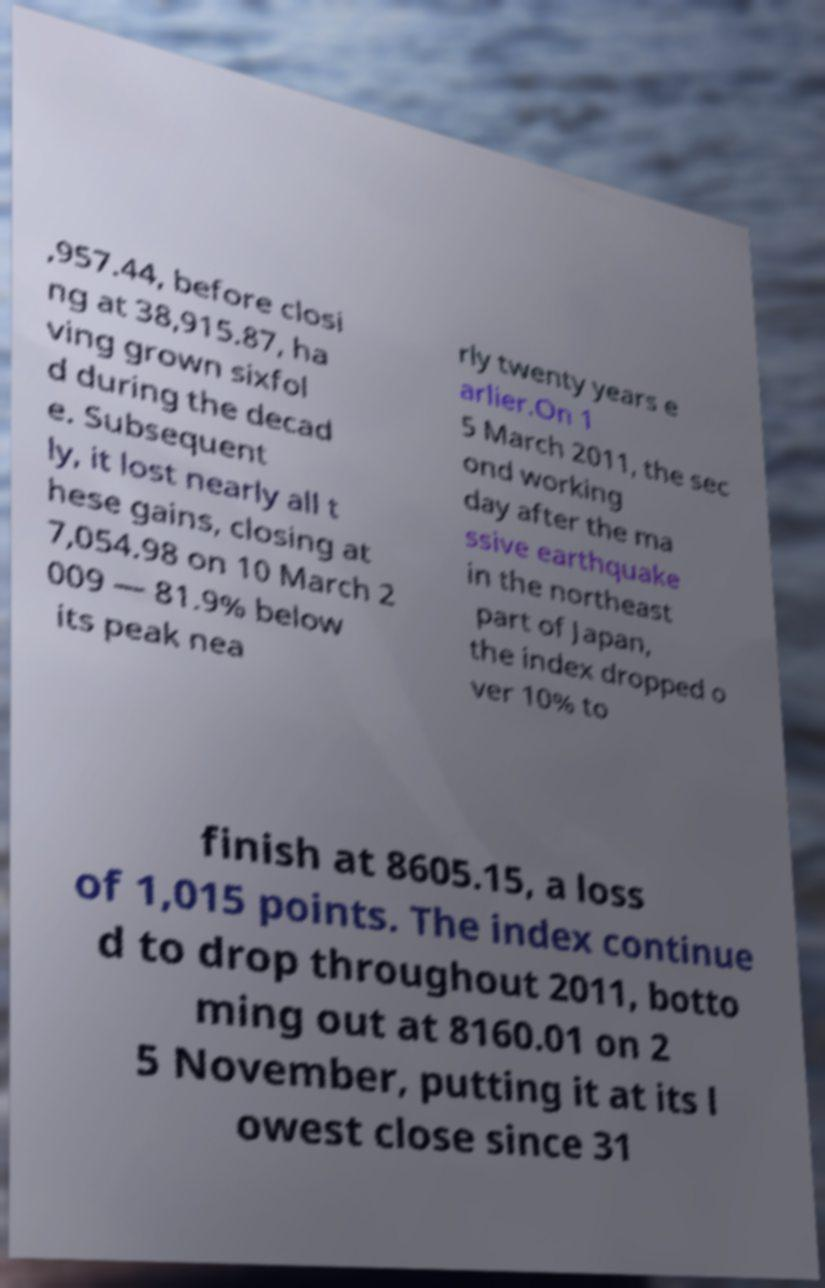For documentation purposes, I need the text within this image transcribed. Could you provide that? ,957.44, before closi ng at 38,915.87, ha ving grown sixfol d during the decad e. Subsequent ly, it lost nearly all t hese gains, closing at 7,054.98 on 10 March 2 009 — 81.9% below its peak nea rly twenty years e arlier.On 1 5 March 2011, the sec ond working day after the ma ssive earthquake in the northeast part of Japan, the index dropped o ver 10% to finish at 8605.15, a loss of 1,015 points. The index continue d to drop throughout 2011, botto ming out at 8160.01 on 2 5 November, putting it at its l owest close since 31 